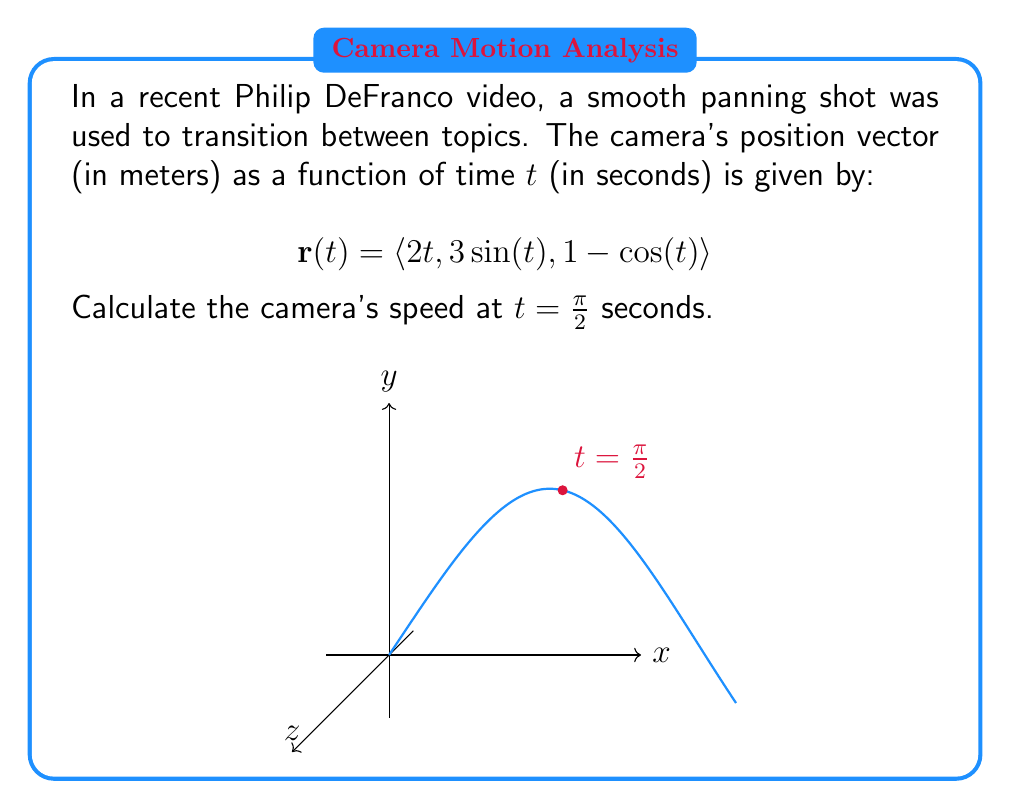What is the answer to this math problem? Let's approach this step-by-step:

1) The speed of the camera is the magnitude of its velocity vector. The velocity vector is the derivative of the position vector with respect to time.

2) First, let's find the velocity vector $\mathbf{v}(t)$ by differentiating $\mathbf{r}(t)$:

   $$\mathbf{v}(t) = \frac{d}{dt}\mathbf{r}(t) = \langle 2, 3\cos(t), \sin(t) \rangle$$

3) The speed is the magnitude of this velocity vector:

   $$\text{speed} = \|\mathbf{v}(t)\| = \sqrt{(2)^2 + (3\cos(t))^2 + (\sin(t))^2}$$

4) We need to evaluate this at t = π/2:

   $$\text{speed at t = π/2} = \sqrt{(2)^2 + (3\cos(\pi/2))^2 + (\sin(\pi/2))^2}$$

5) Simplify:
   - $\cos(\pi/2) = 0$
   - $\sin(\pi/2) = 1$

   $$\text{speed at t = π/2} = \sqrt{4 + 0 + 1} = \sqrt{5}$$

6) Therefore, the camera's speed at t = π/2 seconds is $\sqrt{5}$ meters per second.
Answer: $\sqrt{5}$ m/s 